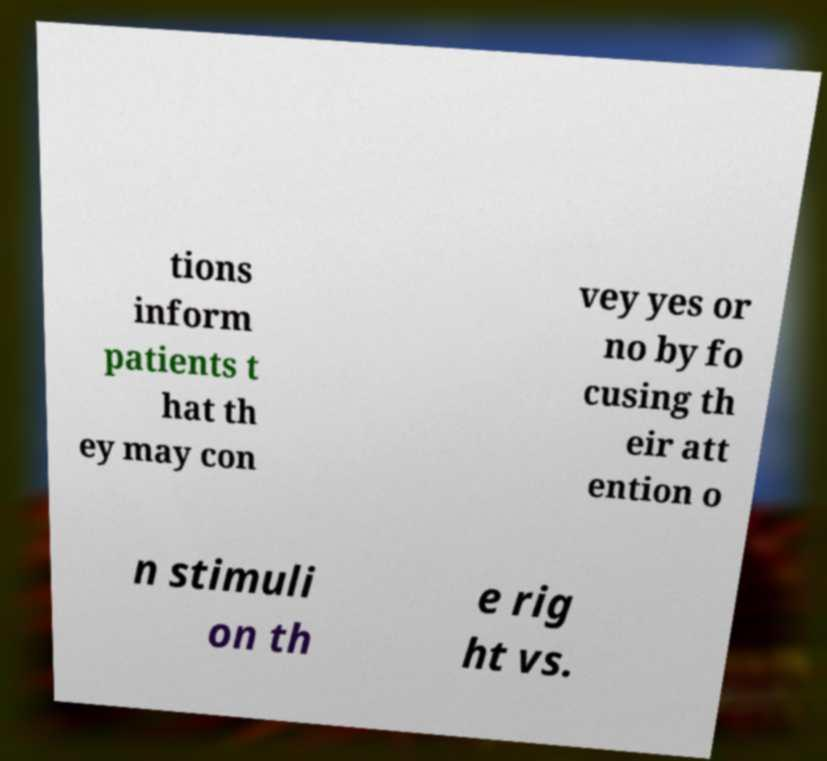Could you extract and type out the text from this image? tions inform patients t hat th ey may con vey yes or no by fo cusing th eir att ention o n stimuli on th e rig ht vs. 